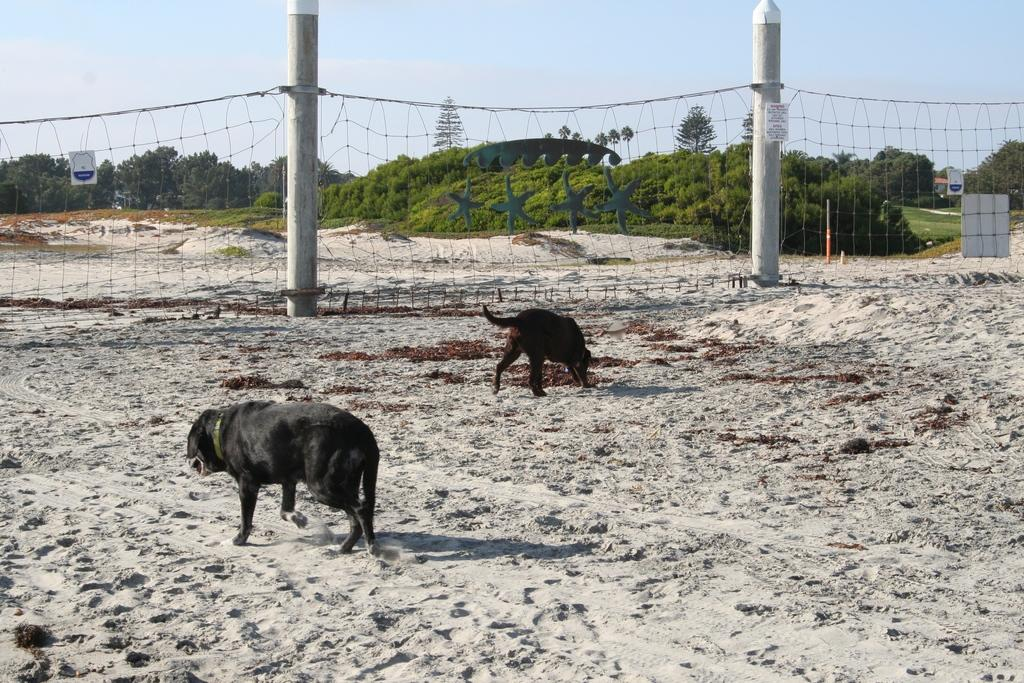How many dogs are present in the image? There are two dogs in the image. What are the dogs doing in the image? The dogs are walking on the sand. What is in front of the dogs? There is a net in front of the dogs. What can be seen in the background of the image? There are trees in the background of the image. What is visible above the scene? The sky is visible above the scene. What type of music can be heard playing in the background of the image? There is no music present in the image; it is a visual representation of the dogs walking on the sand. 